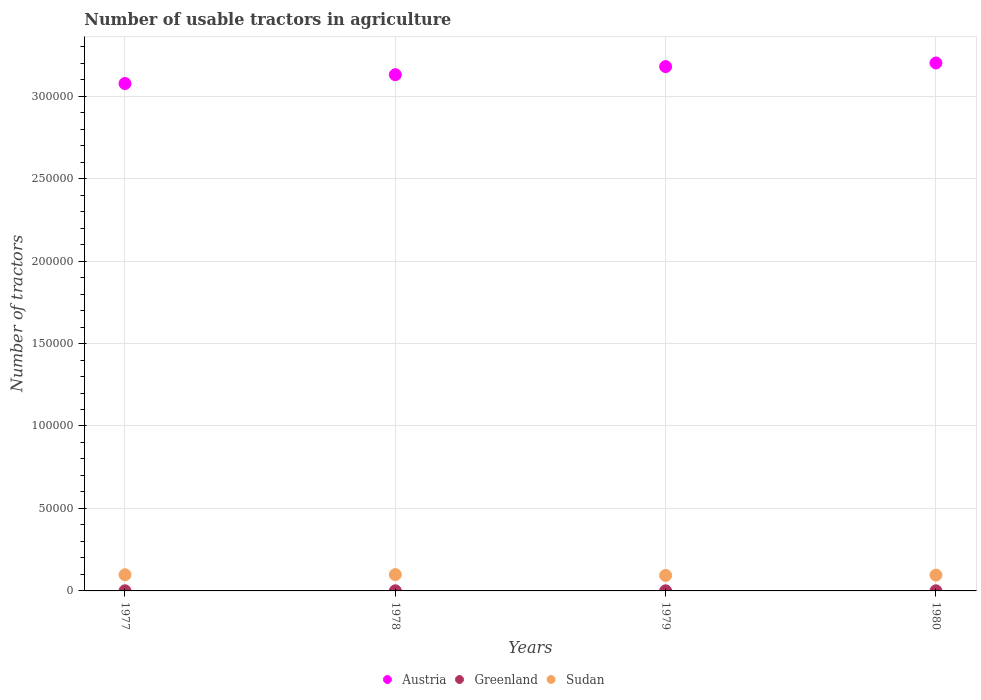How many different coloured dotlines are there?
Keep it short and to the point. 3. What is the number of usable tractors in agriculture in Austria in 1979?
Provide a succinct answer. 3.18e+05. Across all years, what is the maximum number of usable tractors in agriculture in Austria?
Ensure brevity in your answer.  3.20e+05. Across all years, what is the minimum number of usable tractors in agriculture in Sudan?
Provide a succinct answer. 9400. In which year was the number of usable tractors in agriculture in Sudan maximum?
Provide a short and direct response. 1978. What is the total number of usable tractors in agriculture in Austria in the graph?
Offer a terse response. 1.26e+06. What is the difference between the number of usable tractors in agriculture in Austria in 1977 and that in 1978?
Your answer should be very brief. -5363. What is the difference between the number of usable tractors in agriculture in Greenland in 1978 and the number of usable tractors in agriculture in Austria in 1980?
Your answer should be compact. -3.20e+05. What is the average number of usable tractors in agriculture in Sudan per year?
Your answer should be compact. 9675. In the year 1977, what is the difference between the number of usable tractors in agriculture in Greenland and number of usable tractors in agriculture in Austria?
Your response must be concise. -3.08e+05. In how many years, is the number of usable tractors in agriculture in Austria greater than 100000?
Ensure brevity in your answer.  4. What is the ratio of the number of usable tractors in agriculture in Austria in 1978 to that in 1979?
Offer a terse response. 0.98. Is the difference between the number of usable tractors in agriculture in Greenland in 1977 and 1980 greater than the difference between the number of usable tractors in agriculture in Austria in 1977 and 1980?
Your answer should be very brief. Yes. What is the difference between the highest and the second highest number of usable tractors in agriculture in Austria?
Give a very brief answer. 2200. Is the sum of the number of usable tractors in agriculture in Austria in 1978 and 1979 greater than the maximum number of usable tractors in agriculture in Sudan across all years?
Provide a succinct answer. Yes. How many dotlines are there?
Your answer should be very brief. 3. How many years are there in the graph?
Offer a terse response. 4. Are the values on the major ticks of Y-axis written in scientific E-notation?
Give a very brief answer. No. Where does the legend appear in the graph?
Make the answer very short. Bottom center. How many legend labels are there?
Provide a short and direct response. 3. What is the title of the graph?
Offer a very short reply. Number of usable tractors in agriculture. What is the label or title of the X-axis?
Ensure brevity in your answer.  Years. What is the label or title of the Y-axis?
Your response must be concise. Number of tractors. What is the Number of tractors of Austria in 1977?
Offer a very short reply. 3.08e+05. What is the Number of tractors in Greenland in 1977?
Your answer should be compact. 70. What is the Number of tractors of Sudan in 1977?
Your response must be concise. 9800. What is the Number of tractors of Austria in 1978?
Keep it short and to the point. 3.13e+05. What is the Number of tractors in Sudan in 1978?
Give a very brief answer. 9900. What is the Number of tractors of Austria in 1979?
Offer a terse response. 3.18e+05. What is the Number of tractors of Greenland in 1979?
Offer a terse response. 74. What is the Number of tractors in Sudan in 1979?
Provide a succinct answer. 9400. What is the Number of tractors of Austria in 1980?
Offer a terse response. 3.20e+05. What is the Number of tractors of Sudan in 1980?
Your answer should be very brief. 9600. Across all years, what is the maximum Number of tractors in Austria?
Keep it short and to the point. 3.20e+05. Across all years, what is the maximum Number of tractors in Sudan?
Your response must be concise. 9900. Across all years, what is the minimum Number of tractors of Austria?
Provide a succinct answer. 3.08e+05. Across all years, what is the minimum Number of tractors in Sudan?
Your response must be concise. 9400. What is the total Number of tractors of Austria in the graph?
Offer a very short reply. 1.26e+06. What is the total Number of tractors of Greenland in the graph?
Offer a very short reply. 292. What is the total Number of tractors in Sudan in the graph?
Your answer should be very brief. 3.87e+04. What is the difference between the Number of tractors in Austria in 1977 and that in 1978?
Offer a terse response. -5363. What is the difference between the Number of tractors in Greenland in 1977 and that in 1978?
Your answer should be very brief. -2. What is the difference between the Number of tractors of Sudan in 1977 and that in 1978?
Your answer should be very brief. -100. What is the difference between the Number of tractors in Austria in 1977 and that in 1979?
Provide a succinct answer. -1.03e+04. What is the difference between the Number of tractors of Sudan in 1977 and that in 1979?
Your response must be concise. 400. What is the difference between the Number of tractors of Austria in 1977 and that in 1980?
Offer a very short reply. -1.25e+04. What is the difference between the Number of tractors of Austria in 1978 and that in 1979?
Ensure brevity in your answer.  -4900. What is the difference between the Number of tractors in Greenland in 1978 and that in 1979?
Keep it short and to the point. -2. What is the difference between the Number of tractors in Austria in 1978 and that in 1980?
Provide a succinct answer. -7100. What is the difference between the Number of tractors of Sudan in 1978 and that in 1980?
Keep it short and to the point. 300. What is the difference between the Number of tractors in Austria in 1979 and that in 1980?
Offer a very short reply. -2200. What is the difference between the Number of tractors of Greenland in 1979 and that in 1980?
Offer a very short reply. -2. What is the difference between the Number of tractors of Sudan in 1979 and that in 1980?
Keep it short and to the point. -200. What is the difference between the Number of tractors of Austria in 1977 and the Number of tractors of Greenland in 1978?
Your answer should be compact. 3.08e+05. What is the difference between the Number of tractors of Austria in 1977 and the Number of tractors of Sudan in 1978?
Provide a short and direct response. 2.98e+05. What is the difference between the Number of tractors in Greenland in 1977 and the Number of tractors in Sudan in 1978?
Keep it short and to the point. -9830. What is the difference between the Number of tractors of Austria in 1977 and the Number of tractors of Greenland in 1979?
Provide a short and direct response. 3.08e+05. What is the difference between the Number of tractors of Austria in 1977 and the Number of tractors of Sudan in 1979?
Provide a short and direct response. 2.98e+05. What is the difference between the Number of tractors of Greenland in 1977 and the Number of tractors of Sudan in 1979?
Your response must be concise. -9330. What is the difference between the Number of tractors of Austria in 1977 and the Number of tractors of Greenland in 1980?
Give a very brief answer. 3.08e+05. What is the difference between the Number of tractors of Austria in 1977 and the Number of tractors of Sudan in 1980?
Keep it short and to the point. 2.98e+05. What is the difference between the Number of tractors in Greenland in 1977 and the Number of tractors in Sudan in 1980?
Your response must be concise. -9530. What is the difference between the Number of tractors of Austria in 1978 and the Number of tractors of Greenland in 1979?
Make the answer very short. 3.13e+05. What is the difference between the Number of tractors of Austria in 1978 and the Number of tractors of Sudan in 1979?
Your answer should be very brief. 3.04e+05. What is the difference between the Number of tractors in Greenland in 1978 and the Number of tractors in Sudan in 1979?
Ensure brevity in your answer.  -9328. What is the difference between the Number of tractors in Austria in 1978 and the Number of tractors in Greenland in 1980?
Offer a terse response. 3.13e+05. What is the difference between the Number of tractors in Austria in 1978 and the Number of tractors in Sudan in 1980?
Provide a succinct answer. 3.03e+05. What is the difference between the Number of tractors in Greenland in 1978 and the Number of tractors in Sudan in 1980?
Offer a very short reply. -9528. What is the difference between the Number of tractors in Austria in 1979 and the Number of tractors in Greenland in 1980?
Your answer should be very brief. 3.18e+05. What is the difference between the Number of tractors in Austria in 1979 and the Number of tractors in Sudan in 1980?
Offer a terse response. 3.08e+05. What is the difference between the Number of tractors in Greenland in 1979 and the Number of tractors in Sudan in 1980?
Make the answer very short. -9526. What is the average Number of tractors of Austria per year?
Your answer should be very brief. 3.15e+05. What is the average Number of tractors of Sudan per year?
Give a very brief answer. 9675. In the year 1977, what is the difference between the Number of tractors of Austria and Number of tractors of Greenland?
Provide a succinct answer. 3.08e+05. In the year 1977, what is the difference between the Number of tractors in Austria and Number of tractors in Sudan?
Your answer should be compact. 2.98e+05. In the year 1977, what is the difference between the Number of tractors of Greenland and Number of tractors of Sudan?
Your response must be concise. -9730. In the year 1978, what is the difference between the Number of tractors of Austria and Number of tractors of Greenland?
Your answer should be compact. 3.13e+05. In the year 1978, what is the difference between the Number of tractors of Austria and Number of tractors of Sudan?
Your response must be concise. 3.03e+05. In the year 1978, what is the difference between the Number of tractors in Greenland and Number of tractors in Sudan?
Keep it short and to the point. -9828. In the year 1979, what is the difference between the Number of tractors of Austria and Number of tractors of Greenland?
Your response must be concise. 3.18e+05. In the year 1979, what is the difference between the Number of tractors in Austria and Number of tractors in Sudan?
Keep it short and to the point. 3.08e+05. In the year 1979, what is the difference between the Number of tractors in Greenland and Number of tractors in Sudan?
Provide a short and direct response. -9326. In the year 1980, what is the difference between the Number of tractors of Austria and Number of tractors of Greenland?
Keep it short and to the point. 3.20e+05. In the year 1980, what is the difference between the Number of tractors in Austria and Number of tractors in Sudan?
Make the answer very short. 3.10e+05. In the year 1980, what is the difference between the Number of tractors of Greenland and Number of tractors of Sudan?
Offer a very short reply. -9524. What is the ratio of the Number of tractors in Austria in 1977 to that in 1978?
Ensure brevity in your answer.  0.98. What is the ratio of the Number of tractors of Greenland in 1977 to that in 1978?
Offer a terse response. 0.97. What is the ratio of the Number of tractors in Sudan in 1977 to that in 1978?
Ensure brevity in your answer.  0.99. What is the ratio of the Number of tractors in Austria in 1977 to that in 1979?
Make the answer very short. 0.97. What is the ratio of the Number of tractors of Greenland in 1977 to that in 1979?
Provide a short and direct response. 0.95. What is the ratio of the Number of tractors in Sudan in 1977 to that in 1979?
Provide a short and direct response. 1.04. What is the ratio of the Number of tractors in Austria in 1977 to that in 1980?
Provide a succinct answer. 0.96. What is the ratio of the Number of tractors in Greenland in 1977 to that in 1980?
Offer a very short reply. 0.92. What is the ratio of the Number of tractors in Sudan in 1977 to that in 1980?
Your answer should be compact. 1.02. What is the ratio of the Number of tractors in Austria in 1978 to that in 1979?
Your response must be concise. 0.98. What is the ratio of the Number of tractors of Greenland in 1978 to that in 1979?
Your answer should be very brief. 0.97. What is the ratio of the Number of tractors in Sudan in 1978 to that in 1979?
Make the answer very short. 1.05. What is the ratio of the Number of tractors of Austria in 1978 to that in 1980?
Offer a terse response. 0.98. What is the ratio of the Number of tractors of Sudan in 1978 to that in 1980?
Offer a very short reply. 1.03. What is the ratio of the Number of tractors of Austria in 1979 to that in 1980?
Your response must be concise. 0.99. What is the ratio of the Number of tractors of Greenland in 1979 to that in 1980?
Your response must be concise. 0.97. What is the ratio of the Number of tractors in Sudan in 1979 to that in 1980?
Give a very brief answer. 0.98. What is the difference between the highest and the second highest Number of tractors in Austria?
Your answer should be very brief. 2200. What is the difference between the highest and the lowest Number of tractors in Austria?
Ensure brevity in your answer.  1.25e+04. What is the difference between the highest and the lowest Number of tractors in Greenland?
Offer a very short reply. 6. 